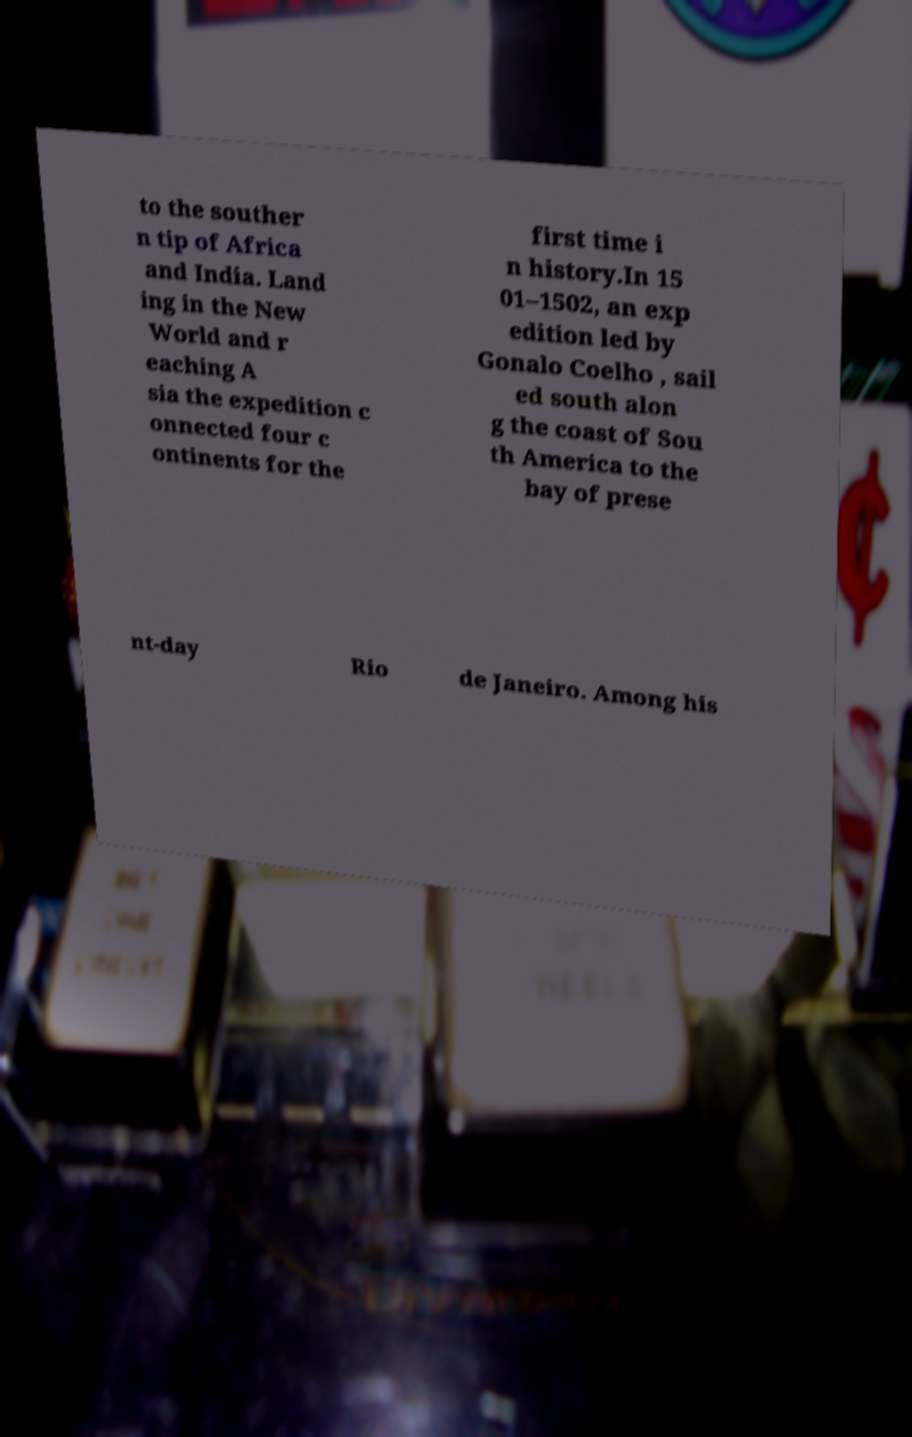Could you extract and type out the text from this image? to the souther n tip of Africa and India. Land ing in the New World and r eaching A sia the expedition c onnected four c ontinents for the first time i n history.In 15 01–1502, an exp edition led by Gonalo Coelho , sail ed south alon g the coast of Sou th America to the bay of prese nt-day Rio de Janeiro. Among his 